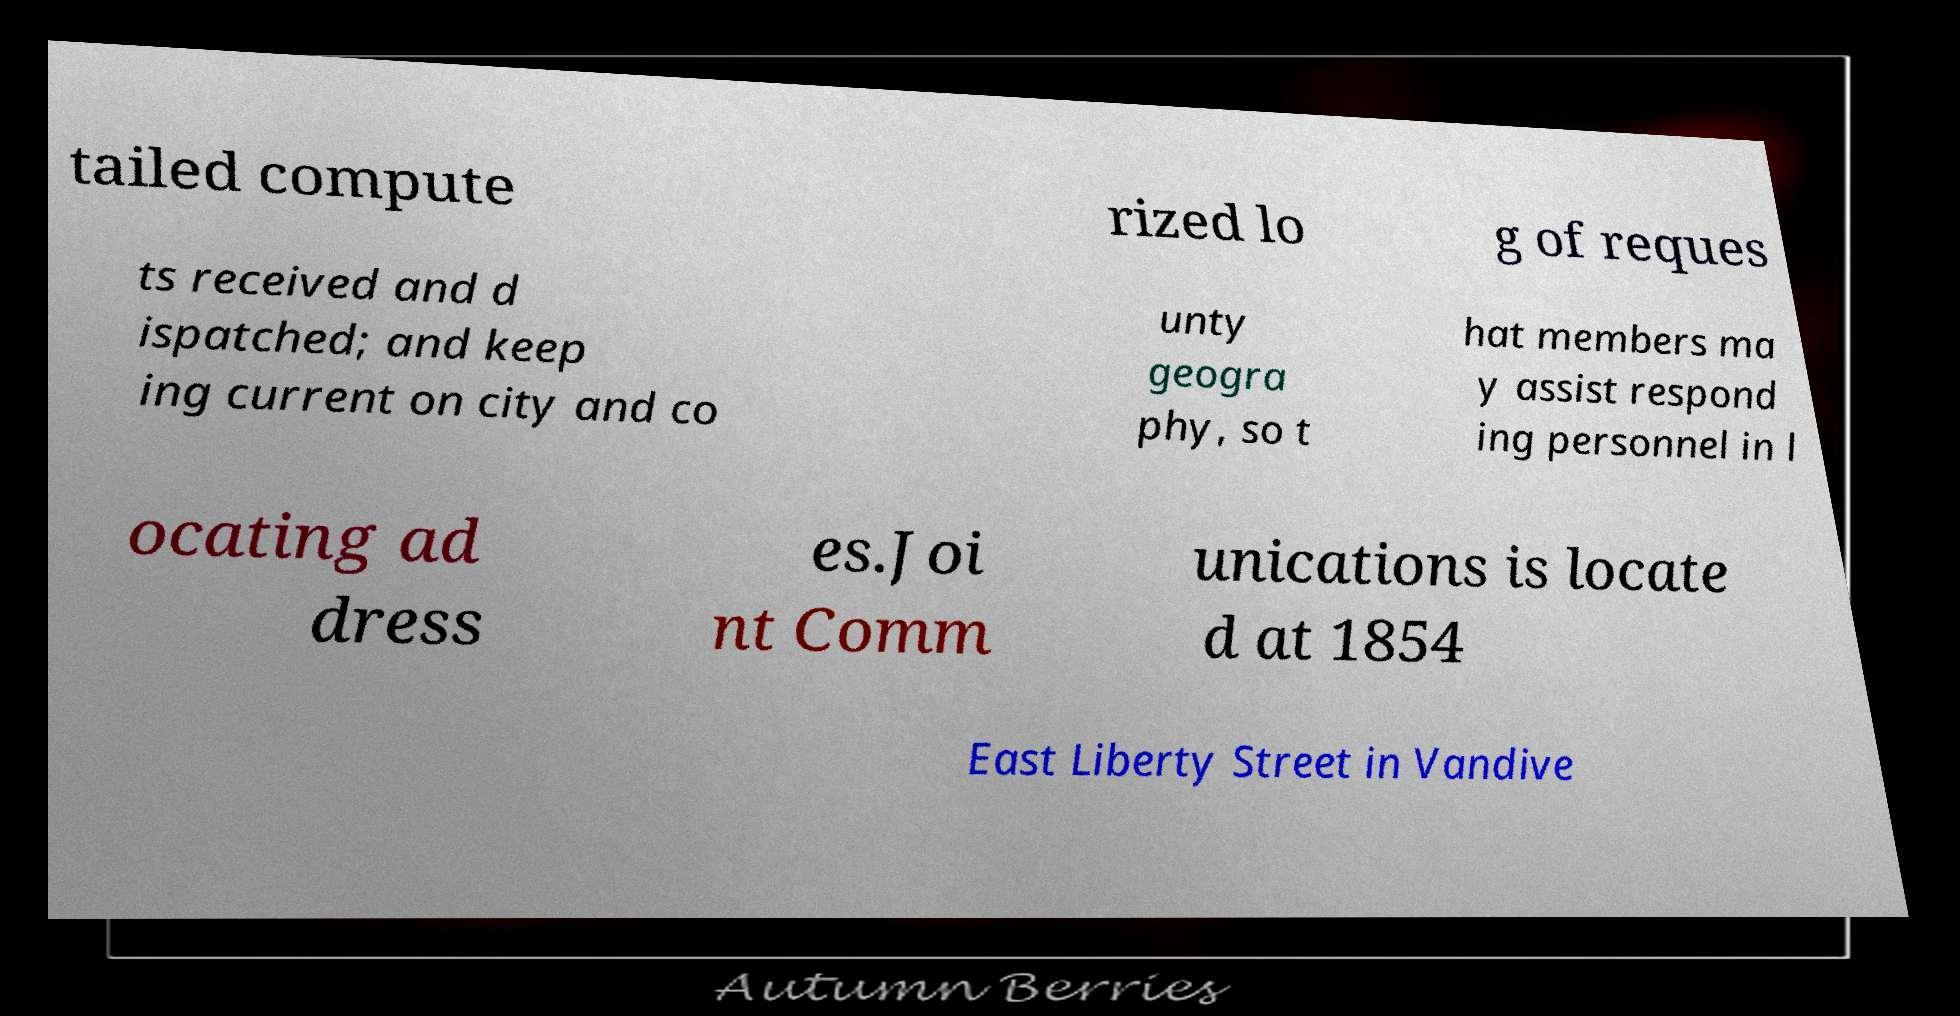Please identify and transcribe the text found in this image. tailed compute rized lo g of reques ts received and d ispatched; and keep ing current on city and co unty geogra phy, so t hat members ma y assist respond ing personnel in l ocating ad dress es.Joi nt Comm unications is locate d at 1854 East Liberty Street in Vandive 